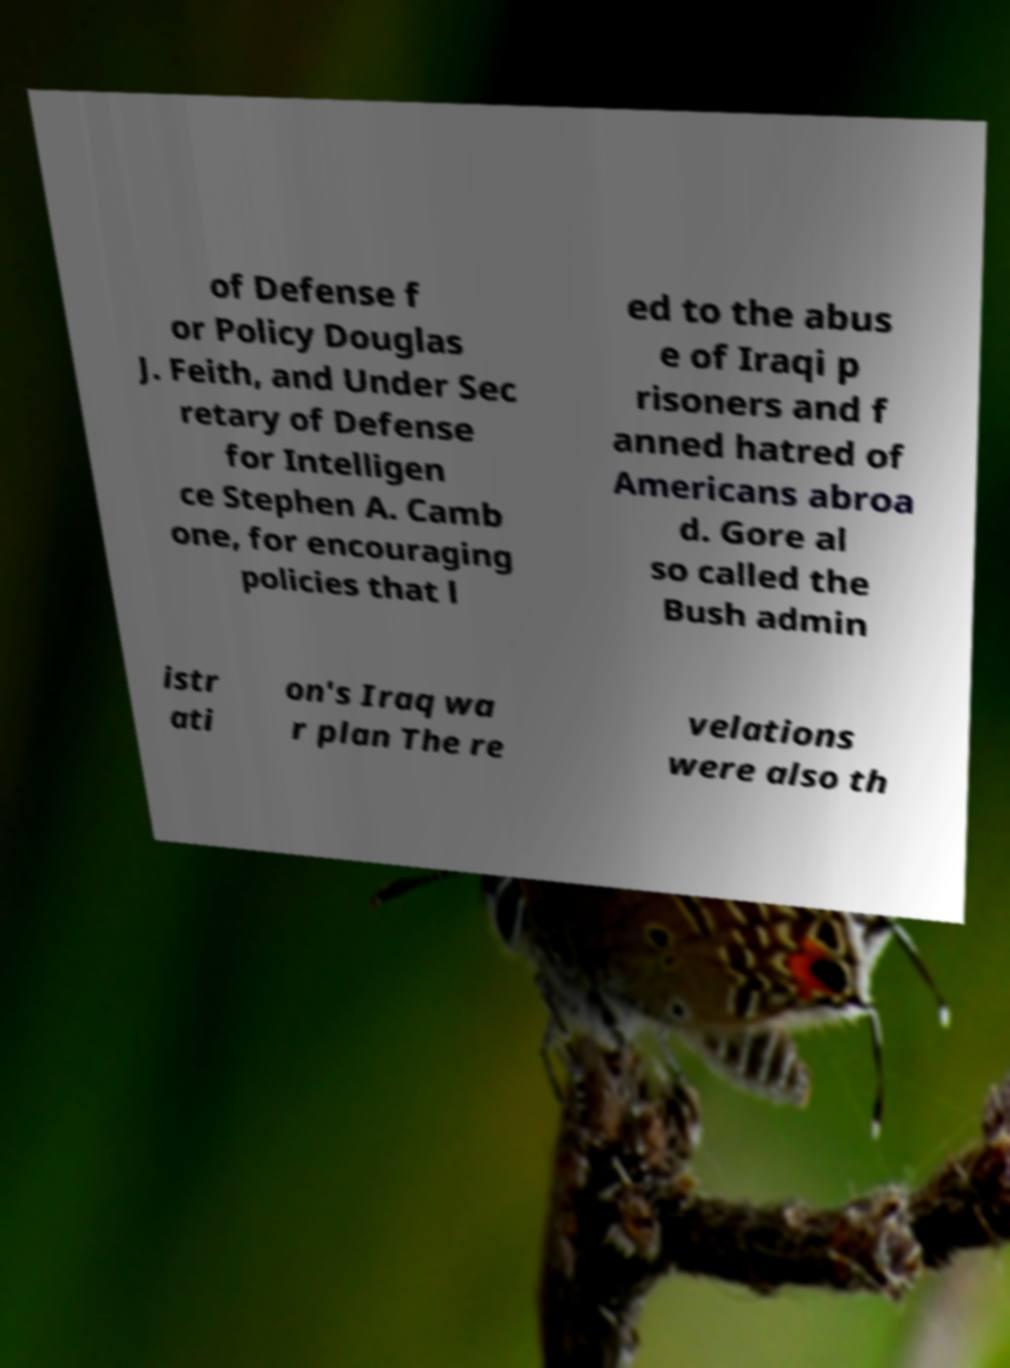Can you accurately transcribe the text from the provided image for me? of Defense f or Policy Douglas J. Feith, and Under Sec retary of Defense for Intelligen ce Stephen A. Camb one, for encouraging policies that l ed to the abus e of Iraqi p risoners and f anned hatred of Americans abroa d. Gore al so called the Bush admin istr ati on's Iraq wa r plan The re velations were also th 